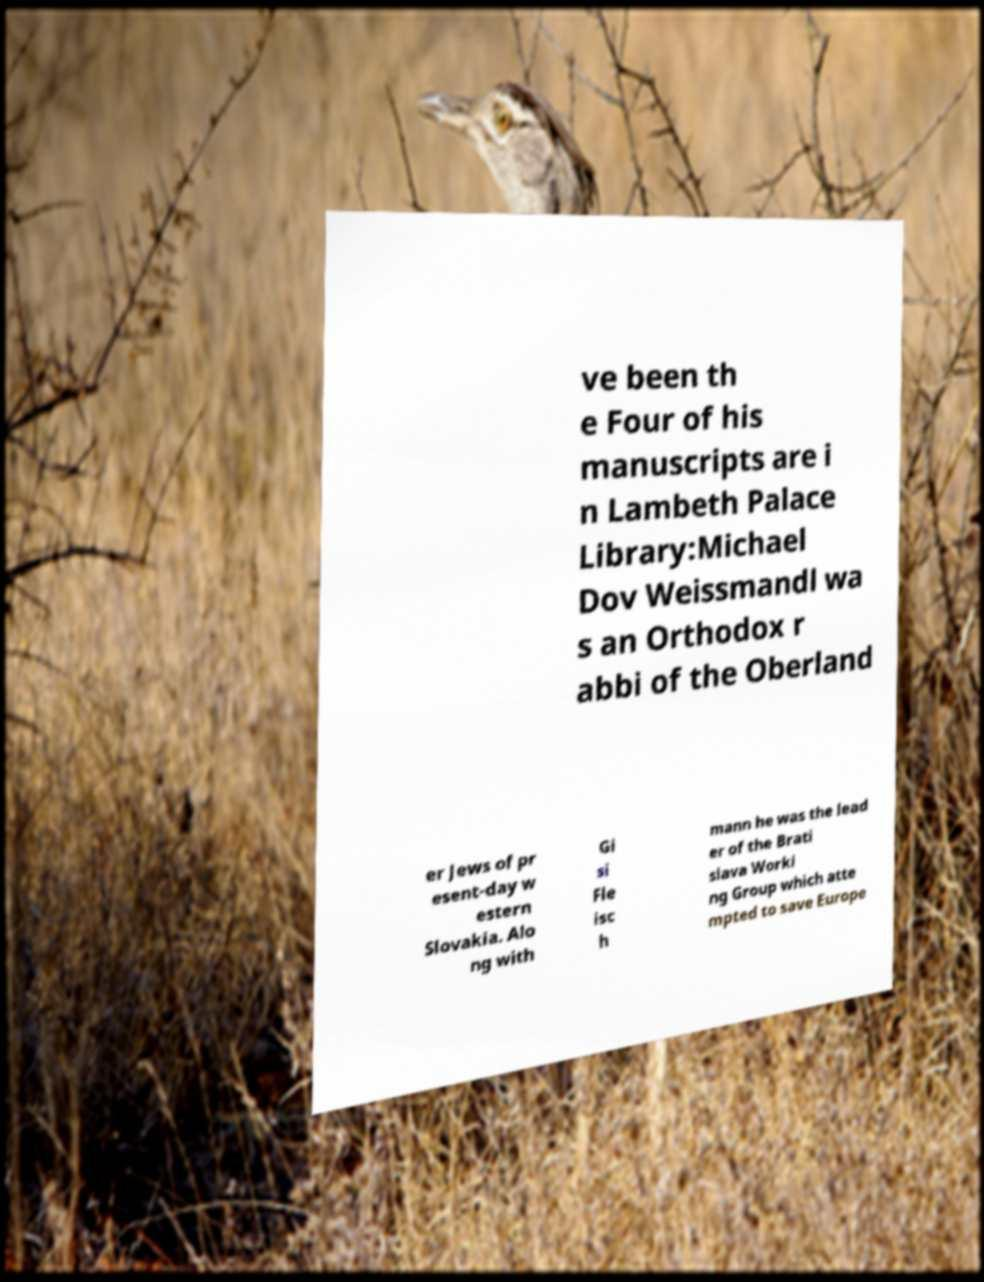I need the written content from this picture converted into text. Can you do that? ve been th e Four of his manuscripts are i n Lambeth Palace Library:Michael Dov Weissmandl wa s an Orthodox r abbi of the Oberland er Jews of pr esent-day w estern Slovakia. Alo ng with Gi si Fle isc h mann he was the lead er of the Brati slava Worki ng Group which atte mpted to save Europe 